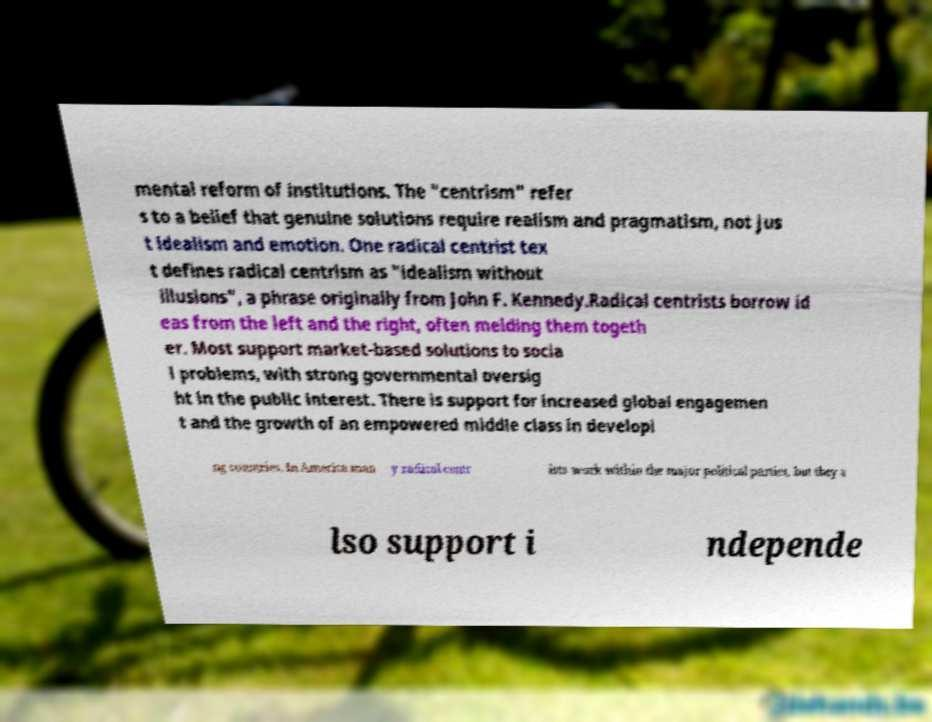Please read and relay the text visible in this image. What does it say? mental reform of institutions. The "centrism" refer s to a belief that genuine solutions require realism and pragmatism, not jus t idealism and emotion. One radical centrist tex t defines radical centrism as "idealism without illusions", a phrase originally from John F. Kennedy.Radical centrists borrow id eas from the left and the right, often melding them togeth er. Most support market-based solutions to socia l problems, with strong governmental oversig ht in the public interest. There is support for increased global engagemen t and the growth of an empowered middle class in developi ng countries. In America man y radical centr ists work within the major political parties, but they a lso support i ndepende 